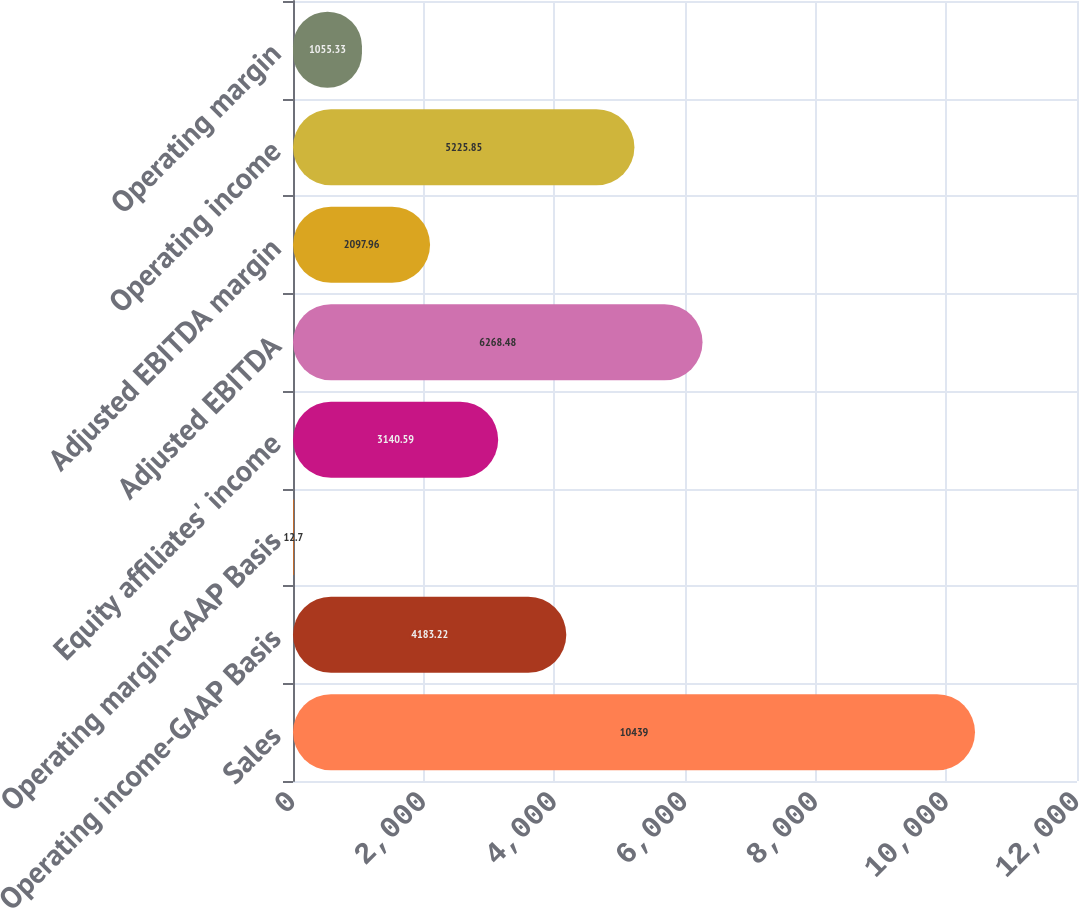Convert chart. <chart><loc_0><loc_0><loc_500><loc_500><bar_chart><fcel>Sales<fcel>Operating income-GAAP Basis<fcel>Operating margin-GAAP Basis<fcel>Equity affiliates' income<fcel>Adjusted EBITDA<fcel>Adjusted EBITDA margin<fcel>Operating income<fcel>Operating margin<nl><fcel>10439<fcel>4183.22<fcel>12.7<fcel>3140.59<fcel>6268.48<fcel>2097.96<fcel>5225.85<fcel>1055.33<nl></chart> 